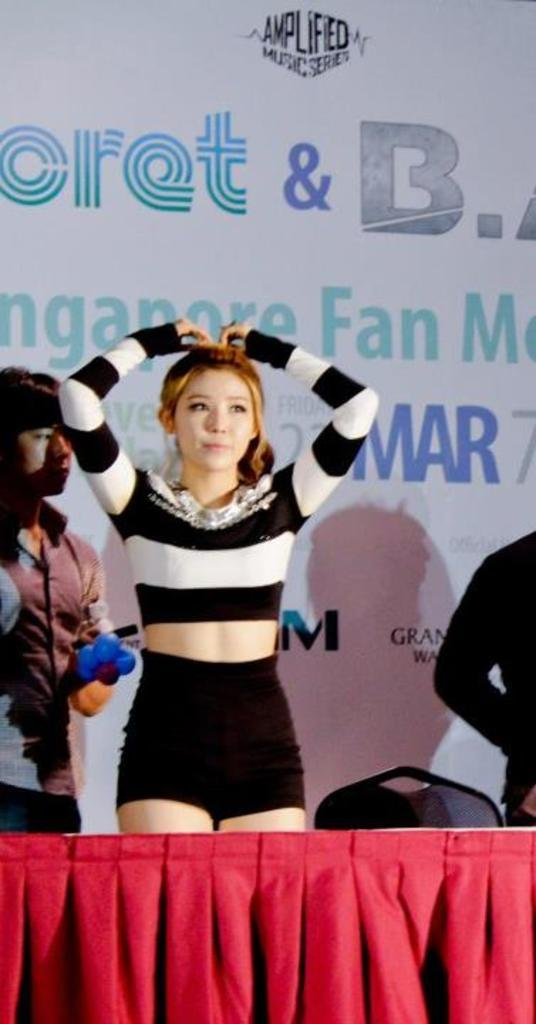<image>
Render a clear and concise summary of the photo. A young lady in a black and white striped shirt stands in front of Amplified Music Series background. 